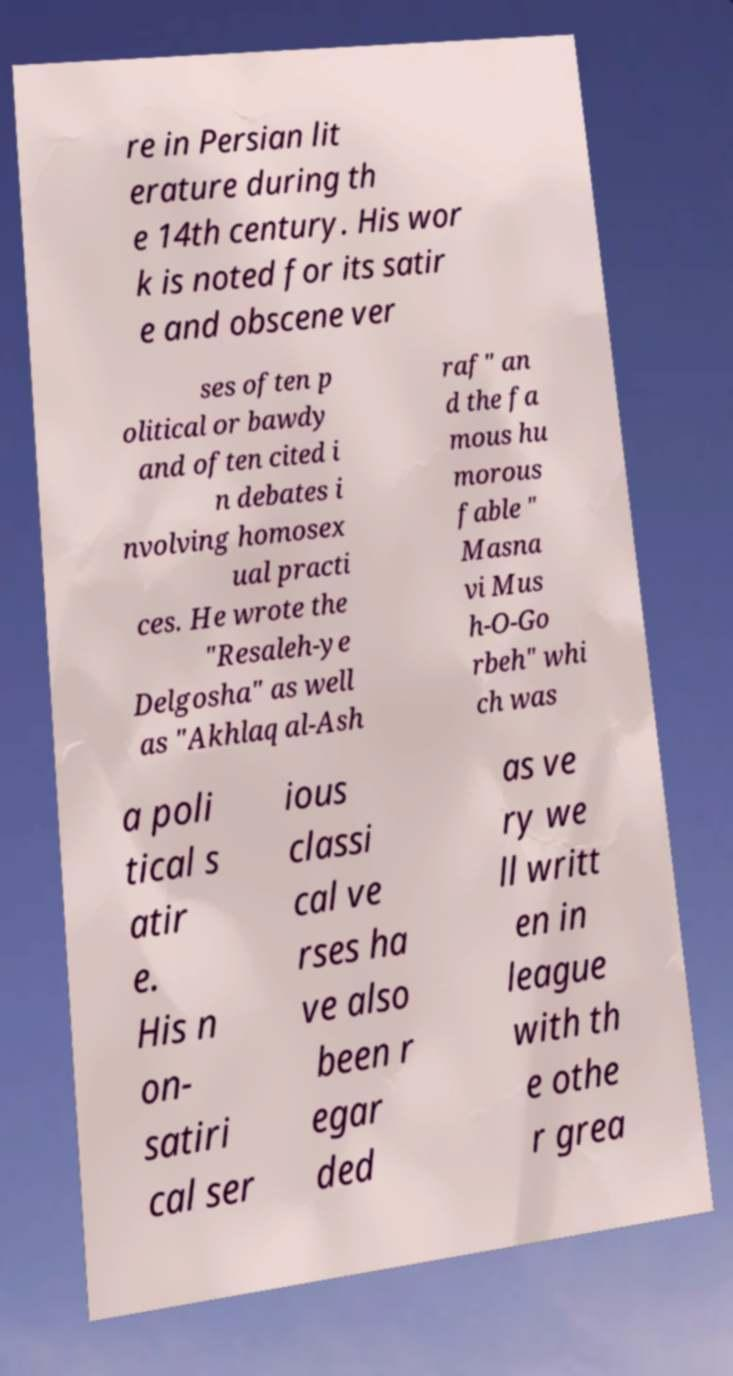Can you accurately transcribe the text from the provided image for me? re in Persian lit erature during th e 14th century. His wor k is noted for its satir e and obscene ver ses often p olitical or bawdy and often cited i n debates i nvolving homosex ual practi ces. He wrote the "Resaleh-ye Delgosha" as well as "Akhlaq al-Ash raf" an d the fa mous hu morous fable " Masna vi Mus h-O-Go rbeh" whi ch was a poli tical s atir e. His n on- satiri cal ser ious classi cal ve rses ha ve also been r egar ded as ve ry we ll writt en in league with th e othe r grea 